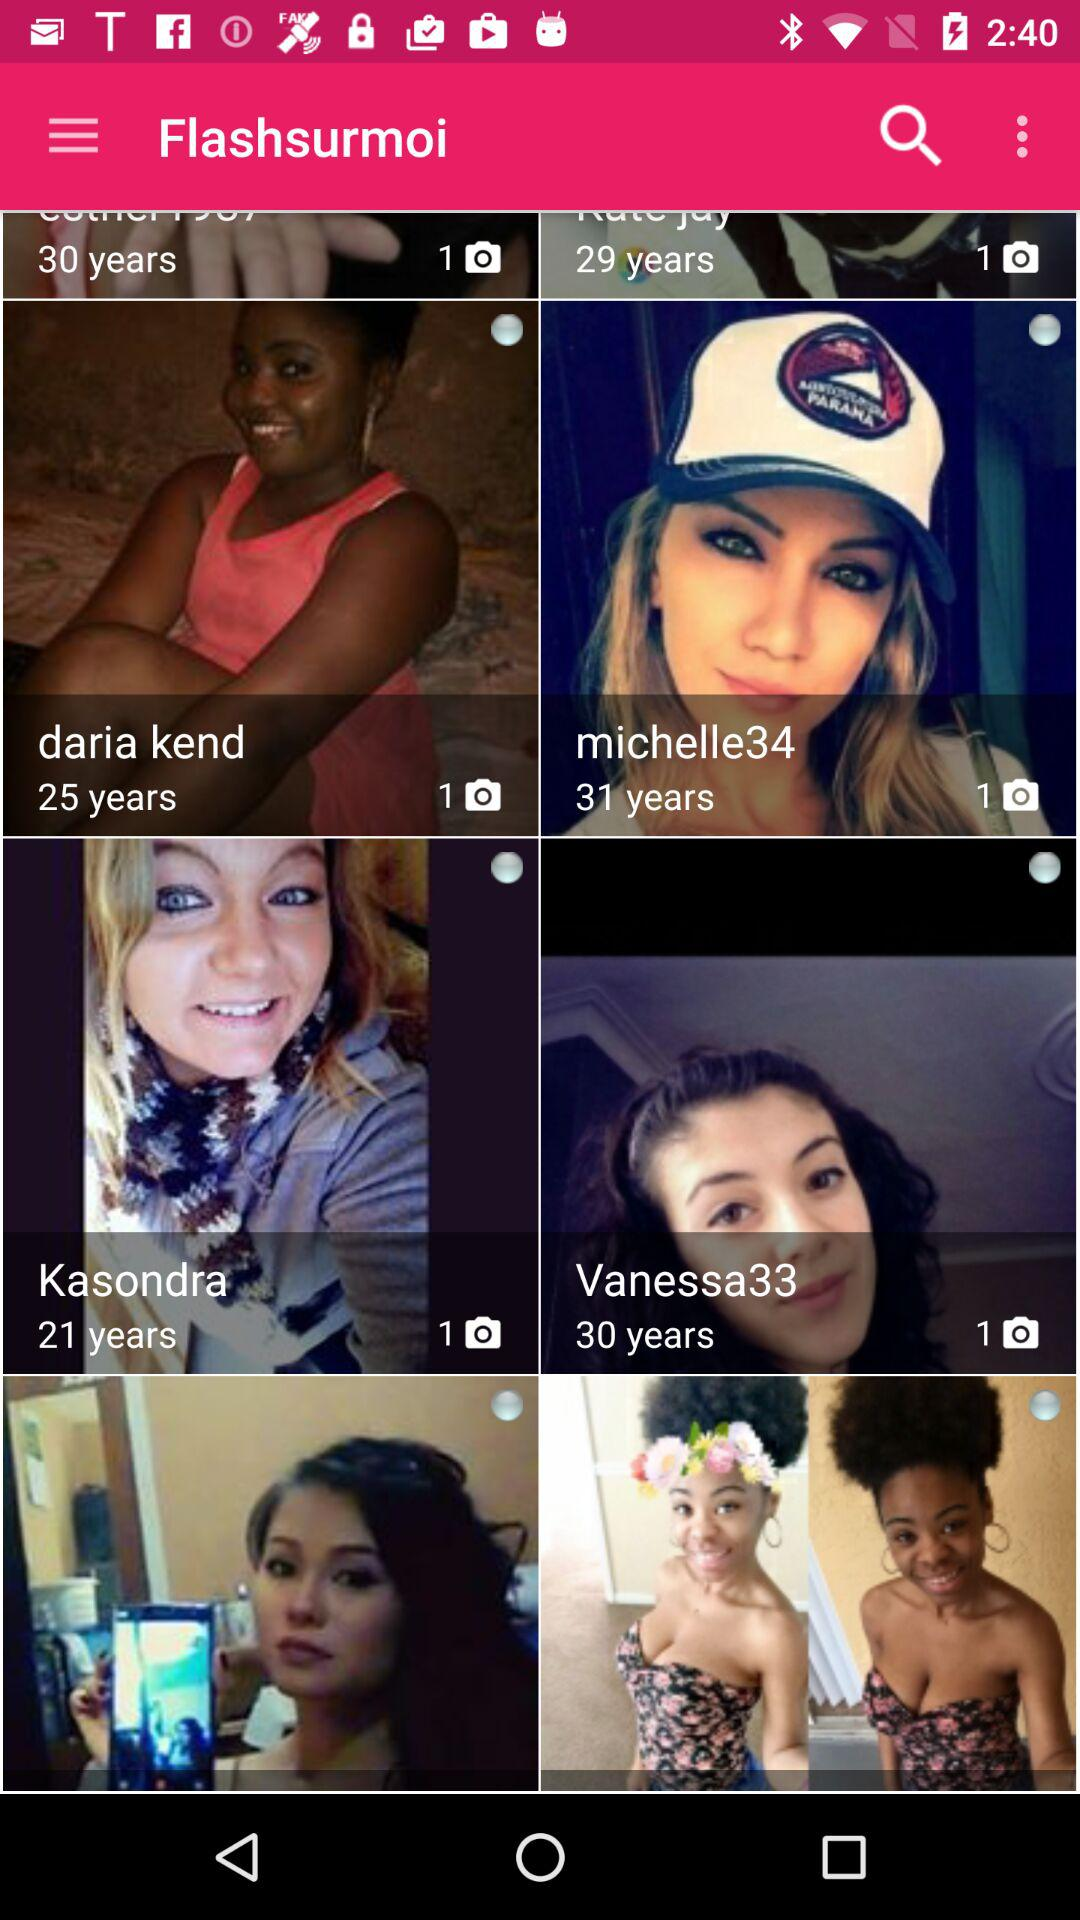What is the age of "michelle34"? The age of "michelle34" is 31 years old. 